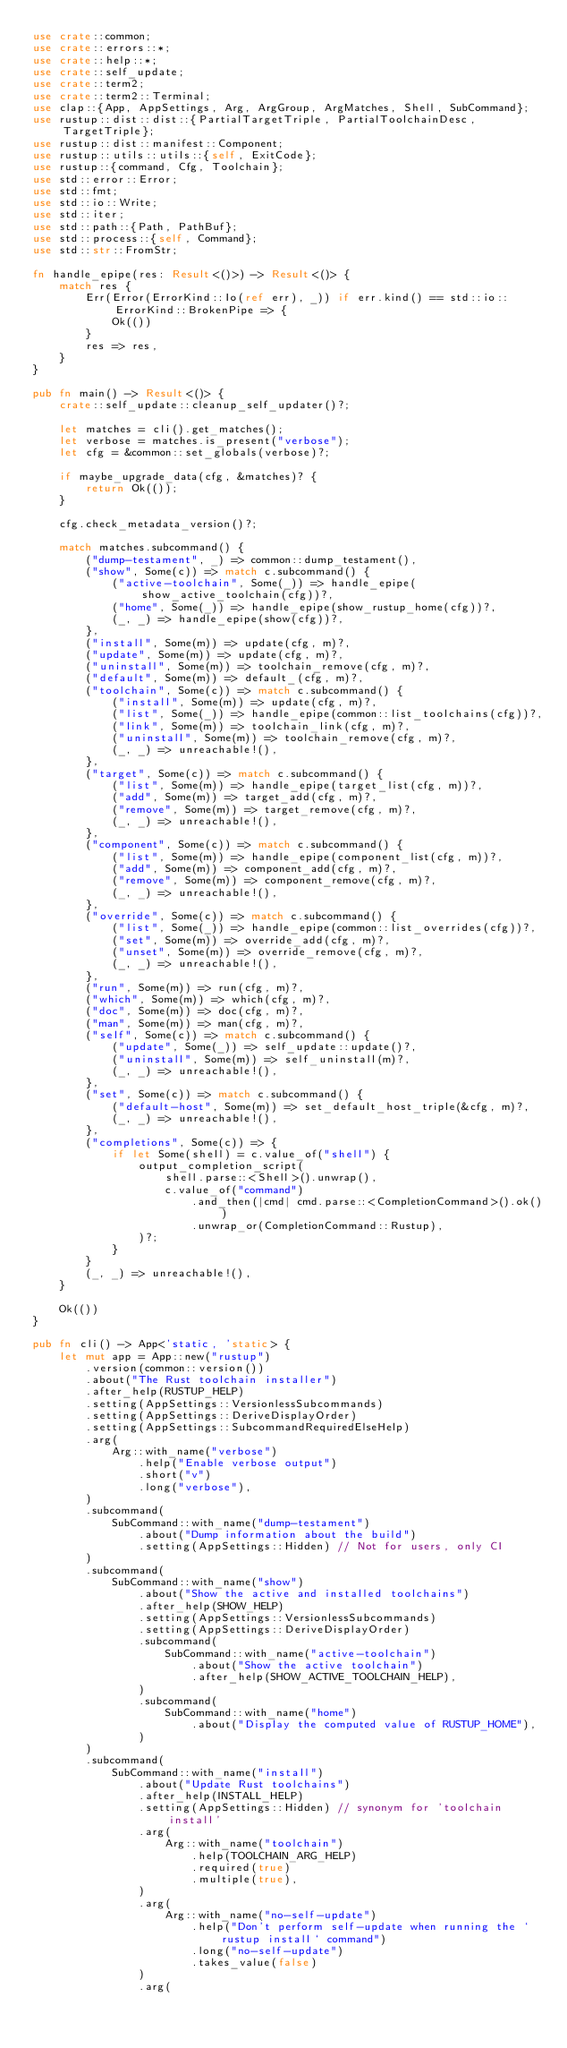<code> <loc_0><loc_0><loc_500><loc_500><_Rust_>use crate::common;
use crate::errors::*;
use crate::help::*;
use crate::self_update;
use crate::term2;
use crate::term2::Terminal;
use clap::{App, AppSettings, Arg, ArgGroup, ArgMatches, Shell, SubCommand};
use rustup::dist::dist::{PartialTargetTriple, PartialToolchainDesc, TargetTriple};
use rustup::dist::manifest::Component;
use rustup::utils::utils::{self, ExitCode};
use rustup::{command, Cfg, Toolchain};
use std::error::Error;
use std::fmt;
use std::io::Write;
use std::iter;
use std::path::{Path, PathBuf};
use std::process::{self, Command};
use std::str::FromStr;

fn handle_epipe(res: Result<()>) -> Result<()> {
    match res {
        Err(Error(ErrorKind::Io(ref err), _)) if err.kind() == std::io::ErrorKind::BrokenPipe => {
            Ok(())
        }
        res => res,
    }
}

pub fn main() -> Result<()> {
    crate::self_update::cleanup_self_updater()?;

    let matches = cli().get_matches();
    let verbose = matches.is_present("verbose");
    let cfg = &common::set_globals(verbose)?;

    if maybe_upgrade_data(cfg, &matches)? {
        return Ok(());
    }

    cfg.check_metadata_version()?;

    match matches.subcommand() {
        ("dump-testament", _) => common::dump_testament(),
        ("show", Some(c)) => match c.subcommand() {
            ("active-toolchain", Some(_)) => handle_epipe(show_active_toolchain(cfg))?,
            ("home", Some(_)) => handle_epipe(show_rustup_home(cfg))?,
            (_, _) => handle_epipe(show(cfg))?,
        },
        ("install", Some(m)) => update(cfg, m)?,
        ("update", Some(m)) => update(cfg, m)?,
        ("uninstall", Some(m)) => toolchain_remove(cfg, m)?,
        ("default", Some(m)) => default_(cfg, m)?,
        ("toolchain", Some(c)) => match c.subcommand() {
            ("install", Some(m)) => update(cfg, m)?,
            ("list", Some(_)) => handle_epipe(common::list_toolchains(cfg))?,
            ("link", Some(m)) => toolchain_link(cfg, m)?,
            ("uninstall", Some(m)) => toolchain_remove(cfg, m)?,
            (_, _) => unreachable!(),
        },
        ("target", Some(c)) => match c.subcommand() {
            ("list", Some(m)) => handle_epipe(target_list(cfg, m))?,
            ("add", Some(m)) => target_add(cfg, m)?,
            ("remove", Some(m)) => target_remove(cfg, m)?,
            (_, _) => unreachable!(),
        },
        ("component", Some(c)) => match c.subcommand() {
            ("list", Some(m)) => handle_epipe(component_list(cfg, m))?,
            ("add", Some(m)) => component_add(cfg, m)?,
            ("remove", Some(m)) => component_remove(cfg, m)?,
            (_, _) => unreachable!(),
        },
        ("override", Some(c)) => match c.subcommand() {
            ("list", Some(_)) => handle_epipe(common::list_overrides(cfg))?,
            ("set", Some(m)) => override_add(cfg, m)?,
            ("unset", Some(m)) => override_remove(cfg, m)?,
            (_, _) => unreachable!(),
        },
        ("run", Some(m)) => run(cfg, m)?,
        ("which", Some(m)) => which(cfg, m)?,
        ("doc", Some(m)) => doc(cfg, m)?,
        ("man", Some(m)) => man(cfg, m)?,
        ("self", Some(c)) => match c.subcommand() {
            ("update", Some(_)) => self_update::update()?,
            ("uninstall", Some(m)) => self_uninstall(m)?,
            (_, _) => unreachable!(),
        },
        ("set", Some(c)) => match c.subcommand() {
            ("default-host", Some(m)) => set_default_host_triple(&cfg, m)?,
            (_, _) => unreachable!(),
        },
        ("completions", Some(c)) => {
            if let Some(shell) = c.value_of("shell") {
                output_completion_script(
                    shell.parse::<Shell>().unwrap(),
                    c.value_of("command")
                        .and_then(|cmd| cmd.parse::<CompletionCommand>().ok())
                        .unwrap_or(CompletionCommand::Rustup),
                )?;
            }
        }
        (_, _) => unreachable!(),
    }

    Ok(())
}

pub fn cli() -> App<'static, 'static> {
    let mut app = App::new("rustup")
        .version(common::version())
        .about("The Rust toolchain installer")
        .after_help(RUSTUP_HELP)
        .setting(AppSettings::VersionlessSubcommands)
        .setting(AppSettings::DeriveDisplayOrder)
        .setting(AppSettings::SubcommandRequiredElseHelp)
        .arg(
            Arg::with_name("verbose")
                .help("Enable verbose output")
                .short("v")
                .long("verbose"),
        )
        .subcommand(
            SubCommand::with_name("dump-testament")
                .about("Dump information about the build")
                .setting(AppSettings::Hidden) // Not for users, only CI
        )
        .subcommand(
            SubCommand::with_name("show")
                .about("Show the active and installed toolchains")
                .after_help(SHOW_HELP)
                .setting(AppSettings::VersionlessSubcommands)
                .setting(AppSettings::DeriveDisplayOrder)
                .subcommand(
                    SubCommand::with_name("active-toolchain")
                        .about("Show the active toolchain")
                        .after_help(SHOW_ACTIVE_TOOLCHAIN_HELP),
                )
                .subcommand(
                    SubCommand::with_name("home")
                        .about("Display the computed value of RUSTUP_HOME"),
                )
        )
        .subcommand(
            SubCommand::with_name("install")
                .about("Update Rust toolchains")
                .after_help(INSTALL_HELP)
                .setting(AppSettings::Hidden) // synonym for 'toolchain install'
                .arg(
                    Arg::with_name("toolchain")
                        .help(TOOLCHAIN_ARG_HELP)
                        .required(true)
                        .multiple(true),
                )
                .arg(
                    Arg::with_name("no-self-update")
                        .help("Don't perform self-update when running the `rustup install` command")
                        .long("no-self-update")
                        .takes_value(false)
                )
                .arg(</code> 